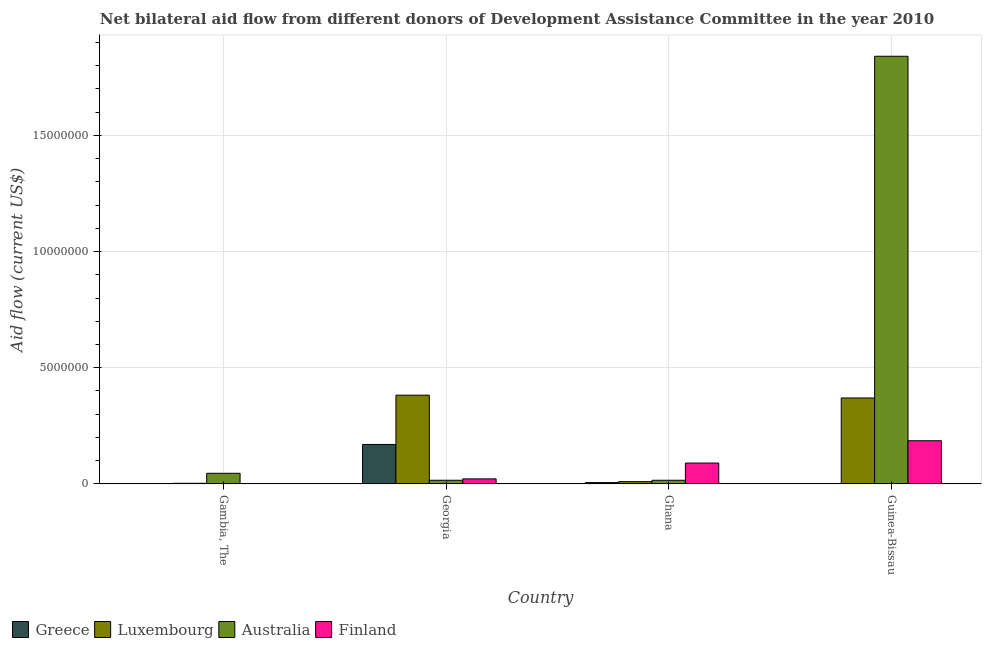How many bars are there on the 1st tick from the right?
Your response must be concise. 4. What is the label of the 4th group of bars from the left?
Provide a succinct answer. Guinea-Bissau. What is the amount of aid given by luxembourg in Georgia?
Provide a succinct answer. 3.82e+06. Across all countries, what is the maximum amount of aid given by luxembourg?
Your response must be concise. 3.82e+06. Across all countries, what is the minimum amount of aid given by luxembourg?
Your answer should be compact. 3.00e+04. In which country was the amount of aid given by luxembourg maximum?
Keep it short and to the point. Georgia. In which country was the amount of aid given by australia minimum?
Ensure brevity in your answer.  Georgia. What is the total amount of aid given by luxembourg in the graph?
Your response must be concise. 7.65e+06. What is the difference between the amount of aid given by finland in Georgia and that in Ghana?
Offer a terse response. -6.80e+05. What is the difference between the amount of aid given by luxembourg in Ghana and the amount of aid given by finland in Georgia?
Keep it short and to the point. -1.20e+05. What is the average amount of aid given by greece per country?
Give a very brief answer. 4.48e+05. What is the difference between the amount of aid given by australia and amount of aid given by finland in Gambia, The?
Your answer should be very brief. 4.40e+05. In how many countries, is the amount of aid given by greece greater than 8000000 US$?
Make the answer very short. 0. What is the ratio of the amount of aid given by australia in Gambia, The to that in Guinea-Bissau?
Make the answer very short. 0.03. What is the difference between the highest and the lowest amount of aid given by greece?
Make the answer very short. 1.69e+06. Is it the case that in every country, the sum of the amount of aid given by greece and amount of aid given by luxembourg is greater than the sum of amount of aid given by finland and amount of aid given by australia?
Provide a succinct answer. No. What does the 4th bar from the right in Ghana represents?
Make the answer very short. Greece. Are all the bars in the graph horizontal?
Your response must be concise. No. How many countries are there in the graph?
Provide a short and direct response. 4. What is the difference between two consecutive major ticks on the Y-axis?
Provide a succinct answer. 5.00e+06. Where does the legend appear in the graph?
Offer a very short reply. Bottom left. How many legend labels are there?
Offer a very short reply. 4. What is the title of the graph?
Keep it short and to the point. Net bilateral aid flow from different donors of Development Assistance Committee in the year 2010. What is the Aid flow (current US$) of Luxembourg in Gambia, The?
Provide a succinct answer. 3.00e+04. What is the Aid flow (current US$) of Australia in Gambia, The?
Your answer should be very brief. 4.60e+05. What is the Aid flow (current US$) in Greece in Georgia?
Your answer should be very brief. 1.70e+06. What is the Aid flow (current US$) in Luxembourg in Georgia?
Provide a short and direct response. 3.82e+06. What is the Aid flow (current US$) in Finland in Georgia?
Offer a terse response. 2.20e+05. What is the Aid flow (current US$) of Luxembourg in Ghana?
Your answer should be compact. 1.00e+05. What is the Aid flow (current US$) of Finland in Ghana?
Your response must be concise. 9.00e+05. What is the Aid flow (current US$) in Greece in Guinea-Bissau?
Ensure brevity in your answer.  10000. What is the Aid flow (current US$) of Luxembourg in Guinea-Bissau?
Your answer should be compact. 3.70e+06. What is the Aid flow (current US$) of Australia in Guinea-Bissau?
Your response must be concise. 1.84e+07. What is the Aid flow (current US$) in Finland in Guinea-Bissau?
Ensure brevity in your answer.  1.86e+06. Across all countries, what is the maximum Aid flow (current US$) of Greece?
Provide a succinct answer. 1.70e+06. Across all countries, what is the maximum Aid flow (current US$) of Luxembourg?
Offer a very short reply. 3.82e+06. Across all countries, what is the maximum Aid flow (current US$) in Australia?
Your response must be concise. 1.84e+07. Across all countries, what is the maximum Aid flow (current US$) of Finland?
Keep it short and to the point. 1.86e+06. Across all countries, what is the minimum Aid flow (current US$) of Australia?
Your response must be concise. 1.60e+05. Across all countries, what is the minimum Aid flow (current US$) of Finland?
Offer a very short reply. 2.00e+04. What is the total Aid flow (current US$) of Greece in the graph?
Your answer should be compact. 1.79e+06. What is the total Aid flow (current US$) of Luxembourg in the graph?
Ensure brevity in your answer.  7.65e+06. What is the total Aid flow (current US$) in Australia in the graph?
Provide a short and direct response. 1.92e+07. What is the total Aid flow (current US$) of Finland in the graph?
Your answer should be compact. 3.00e+06. What is the difference between the Aid flow (current US$) in Greece in Gambia, The and that in Georgia?
Offer a terse response. -1.68e+06. What is the difference between the Aid flow (current US$) in Luxembourg in Gambia, The and that in Georgia?
Keep it short and to the point. -3.79e+06. What is the difference between the Aid flow (current US$) of Australia in Gambia, The and that in Georgia?
Your answer should be very brief. 3.00e+05. What is the difference between the Aid flow (current US$) in Finland in Gambia, The and that in Georgia?
Your answer should be compact. -2.00e+05. What is the difference between the Aid flow (current US$) in Australia in Gambia, The and that in Ghana?
Give a very brief answer. 3.00e+05. What is the difference between the Aid flow (current US$) in Finland in Gambia, The and that in Ghana?
Provide a succinct answer. -8.80e+05. What is the difference between the Aid flow (current US$) in Greece in Gambia, The and that in Guinea-Bissau?
Keep it short and to the point. 10000. What is the difference between the Aid flow (current US$) in Luxembourg in Gambia, The and that in Guinea-Bissau?
Provide a short and direct response. -3.67e+06. What is the difference between the Aid flow (current US$) in Australia in Gambia, The and that in Guinea-Bissau?
Make the answer very short. -1.79e+07. What is the difference between the Aid flow (current US$) in Finland in Gambia, The and that in Guinea-Bissau?
Your answer should be compact. -1.84e+06. What is the difference between the Aid flow (current US$) in Greece in Georgia and that in Ghana?
Give a very brief answer. 1.64e+06. What is the difference between the Aid flow (current US$) of Luxembourg in Georgia and that in Ghana?
Offer a terse response. 3.72e+06. What is the difference between the Aid flow (current US$) of Finland in Georgia and that in Ghana?
Keep it short and to the point. -6.80e+05. What is the difference between the Aid flow (current US$) of Greece in Georgia and that in Guinea-Bissau?
Your answer should be very brief. 1.69e+06. What is the difference between the Aid flow (current US$) of Luxembourg in Georgia and that in Guinea-Bissau?
Keep it short and to the point. 1.20e+05. What is the difference between the Aid flow (current US$) in Australia in Georgia and that in Guinea-Bissau?
Your response must be concise. -1.82e+07. What is the difference between the Aid flow (current US$) of Finland in Georgia and that in Guinea-Bissau?
Make the answer very short. -1.64e+06. What is the difference between the Aid flow (current US$) of Greece in Ghana and that in Guinea-Bissau?
Your answer should be compact. 5.00e+04. What is the difference between the Aid flow (current US$) of Luxembourg in Ghana and that in Guinea-Bissau?
Offer a terse response. -3.60e+06. What is the difference between the Aid flow (current US$) of Australia in Ghana and that in Guinea-Bissau?
Ensure brevity in your answer.  -1.82e+07. What is the difference between the Aid flow (current US$) in Finland in Ghana and that in Guinea-Bissau?
Offer a very short reply. -9.60e+05. What is the difference between the Aid flow (current US$) of Greece in Gambia, The and the Aid flow (current US$) of Luxembourg in Georgia?
Ensure brevity in your answer.  -3.80e+06. What is the difference between the Aid flow (current US$) in Greece in Gambia, The and the Aid flow (current US$) in Finland in Georgia?
Offer a very short reply. -2.00e+05. What is the difference between the Aid flow (current US$) of Australia in Gambia, The and the Aid flow (current US$) of Finland in Georgia?
Offer a terse response. 2.40e+05. What is the difference between the Aid flow (current US$) in Greece in Gambia, The and the Aid flow (current US$) in Luxembourg in Ghana?
Offer a terse response. -8.00e+04. What is the difference between the Aid flow (current US$) in Greece in Gambia, The and the Aid flow (current US$) in Finland in Ghana?
Keep it short and to the point. -8.80e+05. What is the difference between the Aid flow (current US$) of Luxembourg in Gambia, The and the Aid flow (current US$) of Australia in Ghana?
Give a very brief answer. -1.30e+05. What is the difference between the Aid flow (current US$) of Luxembourg in Gambia, The and the Aid flow (current US$) of Finland in Ghana?
Offer a very short reply. -8.70e+05. What is the difference between the Aid flow (current US$) in Australia in Gambia, The and the Aid flow (current US$) in Finland in Ghana?
Offer a terse response. -4.40e+05. What is the difference between the Aid flow (current US$) in Greece in Gambia, The and the Aid flow (current US$) in Luxembourg in Guinea-Bissau?
Make the answer very short. -3.68e+06. What is the difference between the Aid flow (current US$) of Greece in Gambia, The and the Aid flow (current US$) of Australia in Guinea-Bissau?
Ensure brevity in your answer.  -1.84e+07. What is the difference between the Aid flow (current US$) in Greece in Gambia, The and the Aid flow (current US$) in Finland in Guinea-Bissau?
Give a very brief answer. -1.84e+06. What is the difference between the Aid flow (current US$) of Luxembourg in Gambia, The and the Aid flow (current US$) of Australia in Guinea-Bissau?
Your answer should be compact. -1.84e+07. What is the difference between the Aid flow (current US$) of Luxembourg in Gambia, The and the Aid flow (current US$) of Finland in Guinea-Bissau?
Provide a short and direct response. -1.83e+06. What is the difference between the Aid flow (current US$) in Australia in Gambia, The and the Aid flow (current US$) in Finland in Guinea-Bissau?
Provide a succinct answer. -1.40e+06. What is the difference between the Aid flow (current US$) in Greece in Georgia and the Aid flow (current US$) in Luxembourg in Ghana?
Provide a short and direct response. 1.60e+06. What is the difference between the Aid flow (current US$) of Greece in Georgia and the Aid flow (current US$) of Australia in Ghana?
Offer a terse response. 1.54e+06. What is the difference between the Aid flow (current US$) of Luxembourg in Georgia and the Aid flow (current US$) of Australia in Ghana?
Your answer should be very brief. 3.66e+06. What is the difference between the Aid flow (current US$) of Luxembourg in Georgia and the Aid flow (current US$) of Finland in Ghana?
Give a very brief answer. 2.92e+06. What is the difference between the Aid flow (current US$) in Australia in Georgia and the Aid flow (current US$) in Finland in Ghana?
Your answer should be compact. -7.40e+05. What is the difference between the Aid flow (current US$) of Greece in Georgia and the Aid flow (current US$) of Luxembourg in Guinea-Bissau?
Your answer should be compact. -2.00e+06. What is the difference between the Aid flow (current US$) of Greece in Georgia and the Aid flow (current US$) of Australia in Guinea-Bissau?
Offer a terse response. -1.67e+07. What is the difference between the Aid flow (current US$) in Greece in Georgia and the Aid flow (current US$) in Finland in Guinea-Bissau?
Provide a short and direct response. -1.60e+05. What is the difference between the Aid flow (current US$) of Luxembourg in Georgia and the Aid flow (current US$) of Australia in Guinea-Bissau?
Offer a very short reply. -1.46e+07. What is the difference between the Aid flow (current US$) in Luxembourg in Georgia and the Aid flow (current US$) in Finland in Guinea-Bissau?
Make the answer very short. 1.96e+06. What is the difference between the Aid flow (current US$) of Australia in Georgia and the Aid flow (current US$) of Finland in Guinea-Bissau?
Your answer should be compact. -1.70e+06. What is the difference between the Aid flow (current US$) in Greece in Ghana and the Aid flow (current US$) in Luxembourg in Guinea-Bissau?
Give a very brief answer. -3.64e+06. What is the difference between the Aid flow (current US$) of Greece in Ghana and the Aid flow (current US$) of Australia in Guinea-Bissau?
Your answer should be very brief. -1.83e+07. What is the difference between the Aid flow (current US$) in Greece in Ghana and the Aid flow (current US$) in Finland in Guinea-Bissau?
Your answer should be compact. -1.80e+06. What is the difference between the Aid flow (current US$) in Luxembourg in Ghana and the Aid flow (current US$) in Australia in Guinea-Bissau?
Ensure brevity in your answer.  -1.83e+07. What is the difference between the Aid flow (current US$) in Luxembourg in Ghana and the Aid flow (current US$) in Finland in Guinea-Bissau?
Ensure brevity in your answer.  -1.76e+06. What is the difference between the Aid flow (current US$) in Australia in Ghana and the Aid flow (current US$) in Finland in Guinea-Bissau?
Ensure brevity in your answer.  -1.70e+06. What is the average Aid flow (current US$) in Greece per country?
Provide a succinct answer. 4.48e+05. What is the average Aid flow (current US$) of Luxembourg per country?
Ensure brevity in your answer.  1.91e+06. What is the average Aid flow (current US$) of Australia per country?
Provide a succinct answer. 4.80e+06. What is the average Aid flow (current US$) of Finland per country?
Your answer should be very brief. 7.50e+05. What is the difference between the Aid flow (current US$) in Greece and Aid flow (current US$) in Australia in Gambia, The?
Ensure brevity in your answer.  -4.40e+05. What is the difference between the Aid flow (current US$) in Luxembourg and Aid flow (current US$) in Australia in Gambia, The?
Provide a short and direct response. -4.30e+05. What is the difference between the Aid flow (current US$) in Australia and Aid flow (current US$) in Finland in Gambia, The?
Your response must be concise. 4.40e+05. What is the difference between the Aid flow (current US$) in Greece and Aid flow (current US$) in Luxembourg in Georgia?
Keep it short and to the point. -2.12e+06. What is the difference between the Aid flow (current US$) in Greece and Aid flow (current US$) in Australia in Georgia?
Offer a terse response. 1.54e+06. What is the difference between the Aid flow (current US$) in Greece and Aid flow (current US$) in Finland in Georgia?
Give a very brief answer. 1.48e+06. What is the difference between the Aid flow (current US$) in Luxembourg and Aid flow (current US$) in Australia in Georgia?
Give a very brief answer. 3.66e+06. What is the difference between the Aid flow (current US$) in Luxembourg and Aid flow (current US$) in Finland in Georgia?
Provide a succinct answer. 3.60e+06. What is the difference between the Aid flow (current US$) of Australia and Aid flow (current US$) of Finland in Georgia?
Offer a terse response. -6.00e+04. What is the difference between the Aid flow (current US$) in Greece and Aid flow (current US$) in Luxembourg in Ghana?
Keep it short and to the point. -4.00e+04. What is the difference between the Aid flow (current US$) in Greece and Aid flow (current US$) in Finland in Ghana?
Provide a short and direct response. -8.40e+05. What is the difference between the Aid flow (current US$) in Luxembourg and Aid flow (current US$) in Australia in Ghana?
Make the answer very short. -6.00e+04. What is the difference between the Aid flow (current US$) of Luxembourg and Aid flow (current US$) of Finland in Ghana?
Make the answer very short. -8.00e+05. What is the difference between the Aid flow (current US$) in Australia and Aid flow (current US$) in Finland in Ghana?
Offer a very short reply. -7.40e+05. What is the difference between the Aid flow (current US$) in Greece and Aid flow (current US$) in Luxembourg in Guinea-Bissau?
Provide a succinct answer. -3.69e+06. What is the difference between the Aid flow (current US$) in Greece and Aid flow (current US$) in Australia in Guinea-Bissau?
Offer a very short reply. -1.84e+07. What is the difference between the Aid flow (current US$) in Greece and Aid flow (current US$) in Finland in Guinea-Bissau?
Ensure brevity in your answer.  -1.85e+06. What is the difference between the Aid flow (current US$) in Luxembourg and Aid flow (current US$) in Australia in Guinea-Bissau?
Offer a terse response. -1.47e+07. What is the difference between the Aid flow (current US$) in Luxembourg and Aid flow (current US$) in Finland in Guinea-Bissau?
Your answer should be very brief. 1.84e+06. What is the difference between the Aid flow (current US$) of Australia and Aid flow (current US$) of Finland in Guinea-Bissau?
Your response must be concise. 1.65e+07. What is the ratio of the Aid flow (current US$) in Greece in Gambia, The to that in Georgia?
Provide a short and direct response. 0.01. What is the ratio of the Aid flow (current US$) of Luxembourg in Gambia, The to that in Georgia?
Your response must be concise. 0.01. What is the ratio of the Aid flow (current US$) of Australia in Gambia, The to that in Georgia?
Offer a very short reply. 2.88. What is the ratio of the Aid flow (current US$) of Finland in Gambia, The to that in Georgia?
Your answer should be very brief. 0.09. What is the ratio of the Aid flow (current US$) of Australia in Gambia, The to that in Ghana?
Your answer should be very brief. 2.88. What is the ratio of the Aid flow (current US$) in Finland in Gambia, The to that in Ghana?
Keep it short and to the point. 0.02. What is the ratio of the Aid flow (current US$) of Greece in Gambia, The to that in Guinea-Bissau?
Keep it short and to the point. 2. What is the ratio of the Aid flow (current US$) of Luxembourg in Gambia, The to that in Guinea-Bissau?
Offer a terse response. 0.01. What is the ratio of the Aid flow (current US$) in Australia in Gambia, The to that in Guinea-Bissau?
Provide a short and direct response. 0.03. What is the ratio of the Aid flow (current US$) of Finland in Gambia, The to that in Guinea-Bissau?
Provide a succinct answer. 0.01. What is the ratio of the Aid flow (current US$) of Greece in Georgia to that in Ghana?
Give a very brief answer. 28.33. What is the ratio of the Aid flow (current US$) in Luxembourg in Georgia to that in Ghana?
Provide a succinct answer. 38.2. What is the ratio of the Aid flow (current US$) of Finland in Georgia to that in Ghana?
Offer a terse response. 0.24. What is the ratio of the Aid flow (current US$) of Greece in Georgia to that in Guinea-Bissau?
Your answer should be compact. 170. What is the ratio of the Aid flow (current US$) of Luxembourg in Georgia to that in Guinea-Bissau?
Provide a succinct answer. 1.03. What is the ratio of the Aid flow (current US$) of Australia in Georgia to that in Guinea-Bissau?
Make the answer very short. 0.01. What is the ratio of the Aid flow (current US$) in Finland in Georgia to that in Guinea-Bissau?
Provide a short and direct response. 0.12. What is the ratio of the Aid flow (current US$) in Greece in Ghana to that in Guinea-Bissau?
Give a very brief answer. 6. What is the ratio of the Aid flow (current US$) of Luxembourg in Ghana to that in Guinea-Bissau?
Offer a terse response. 0.03. What is the ratio of the Aid flow (current US$) of Australia in Ghana to that in Guinea-Bissau?
Provide a short and direct response. 0.01. What is the ratio of the Aid flow (current US$) in Finland in Ghana to that in Guinea-Bissau?
Provide a short and direct response. 0.48. What is the difference between the highest and the second highest Aid flow (current US$) of Greece?
Your response must be concise. 1.64e+06. What is the difference between the highest and the second highest Aid flow (current US$) in Luxembourg?
Keep it short and to the point. 1.20e+05. What is the difference between the highest and the second highest Aid flow (current US$) of Australia?
Provide a short and direct response. 1.79e+07. What is the difference between the highest and the second highest Aid flow (current US$) of Finland?
Offer a terse response. 9.60e+05. What is the difference between the highest and the lowest Aid flow (current US$) in Greece?
Ensure brevity in your answer.  1.69e+06. What is the difference between the highest and the lowest Aid flow (current US$) of Luxembourg?
Offer a very short reply. 3.79e+06. What is the difference between the highest and the lowest Aid flow (current US$) in Australia?
Your response must be concise. 1.82e+07. What is the difference between the highest and the lowest Aid flow (current US$) of Finland?
Your answer should be very brief. 1.84e+06. 